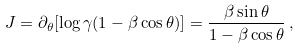Convert formula to latex. <formula><loc_0><loc_0><loc_500><loc_500>J = \partial _ { \theta } [ \log { \gamma ( 1 - \beta \cos \theta ) } ] = \frac { \beta \sin \theta } { 1 - \beta \cos \theta } \, ,</formula> 